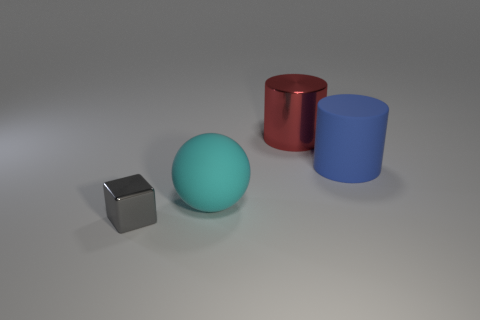Add 3 small metal cubes. How many objects exist? 7 Subtract all balls. How many objects are left? 3 Subtract 1 cyan balls. How many objects are left? 3 Subtract all large blue matte cylinders. Subtract all large red things. How many objects are left? 2 Add 1 cyan objects. How many cyan objects are left? 2 Add 1 metallic cubes. How many metallic cubes exist? 2 